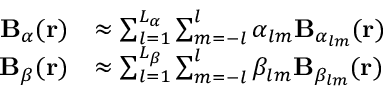Convert formula to latex. <formula><loc_0><loc_0><loc_500><loc_500>\begin{array} { r l } { B _ { \alpha } ( r ) } & { \approx \sum _ { l = 1 } ^ { L _ { \alpha } } \sum _ { m = - l } ^ { l } \alpha _ { l m } B _ { \alpha _ { l m } } ( r ) } \\ { B _ { \beta } ( r ) } & { \approx \sum _ { l = 1 } ^ { L _ { \beta } } \sum _ { m = - l } ^ { l } \beta _ { l m } B _ { \beta _ { l m } } ( r ) } \end{array}</formula> 